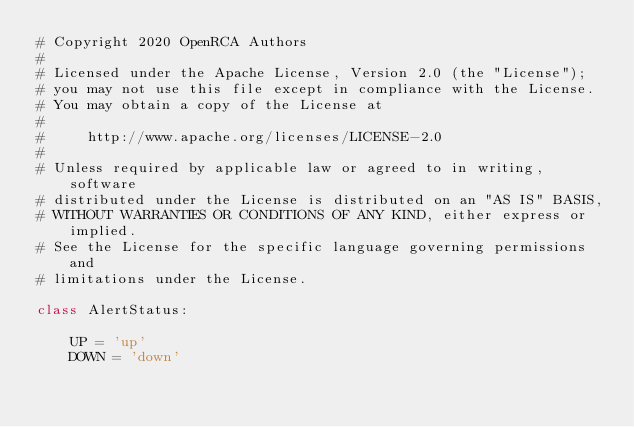Convert code to text. <code><loc_0><loc_0><loc_500><loc_500><_Python_># Copyright 2020 OpenRCA Authors
#
# Licensed under the Apache License, Version 2.0 (the "License");
# you may not use this file except in compliance with the License.
# You may obtain a copy of the License at
#
#     http://www.apache.org/licenses/LICENSE-2.0
#
# Unless required by applicable law or agreed to in writing, software
# distributed under the License is distributed on an "AS IS" BASIS,
# WITHOUT WARRANTIES OR CONDITIONS OF ANY KIND, either express or implied.
# See the License for the specific language governing permissions and
# limitations under the License.

class AlertStatus:

    UP = 'up'
    DOWN = 'down'
</code> 